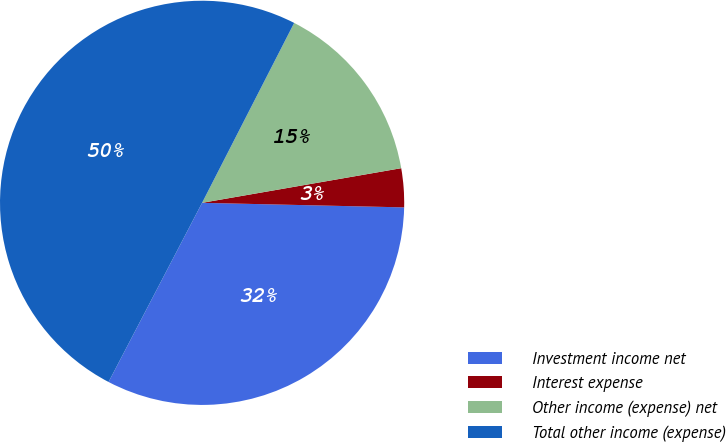Convert chart to OTSL. <chart><loc_0><loc_0><loc_500><loc_500><pie_chart><fcel>Investment income net<fcel>Interest expense<fcel>Other income (expense) net<fcel>Total other income (expense)<nl><fcel>32.3%<fcel>3.1%<fcel>14.73%<fcel>49.87%<nl></chart> 